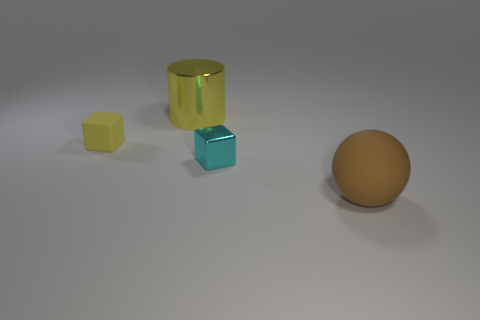Is there any other thing that is the same shape as the brown matte thing?
Offer a very short reply. No. How many spheres are yellow objects or small matte objects?
Make the answer very short. 0. How many purple matte cylinders are there?
Your answer should be compact. 0. How big is the yellow thing behind the matte thing behind the large brown ball?
Ensure brevity in your answer.  Large. How many yellow cubes are in front of the shiny cylinder?
Your response must be concise. 1. The yellow rubber object has what size?
Provide a short and direct response. Small. Are the yellow thing that is on the right side of the tiny yellow rubber cube and the large object in front of the cylinder made of the same material?
Provide a short and direct response. No. Is there a big cylinder of the same color as the tiny matte block?
Provide a short and direct response. Yes. What is the color of the matte object that is the same size as the yellow shiny cylinder?
Keep it short and to the point. Brown. Is the color of the big thing behind the brown matte sphere the same as the tiny rubber cube?
Provide a short and direct response. Yes. 